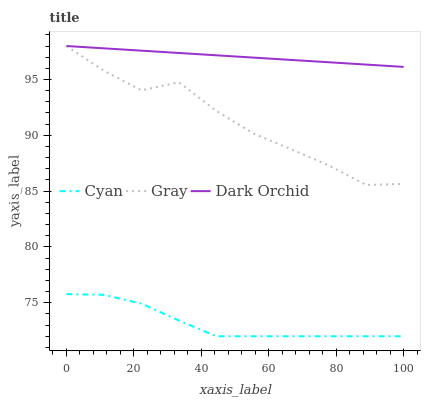Does Gray have the minimum area under the curve?
Answer yes or no. No. Does Gray have the maximum area under the curve?
Answer yes or no. No. Is Gray the smoothest?
Answer yes or no. No. Is Dark Orchid the roughest?
Answer yes or no. No. Does Gray have the lowest value?
Answer yes or no. No. Is Cyan less than Dark Orchid?
Answer yes or no. Yes. Is Gray greater than Cyan?
Answer yes or no. Yes. Does Cyan intersect Dark Orchid?
Answer yes or no. No. 